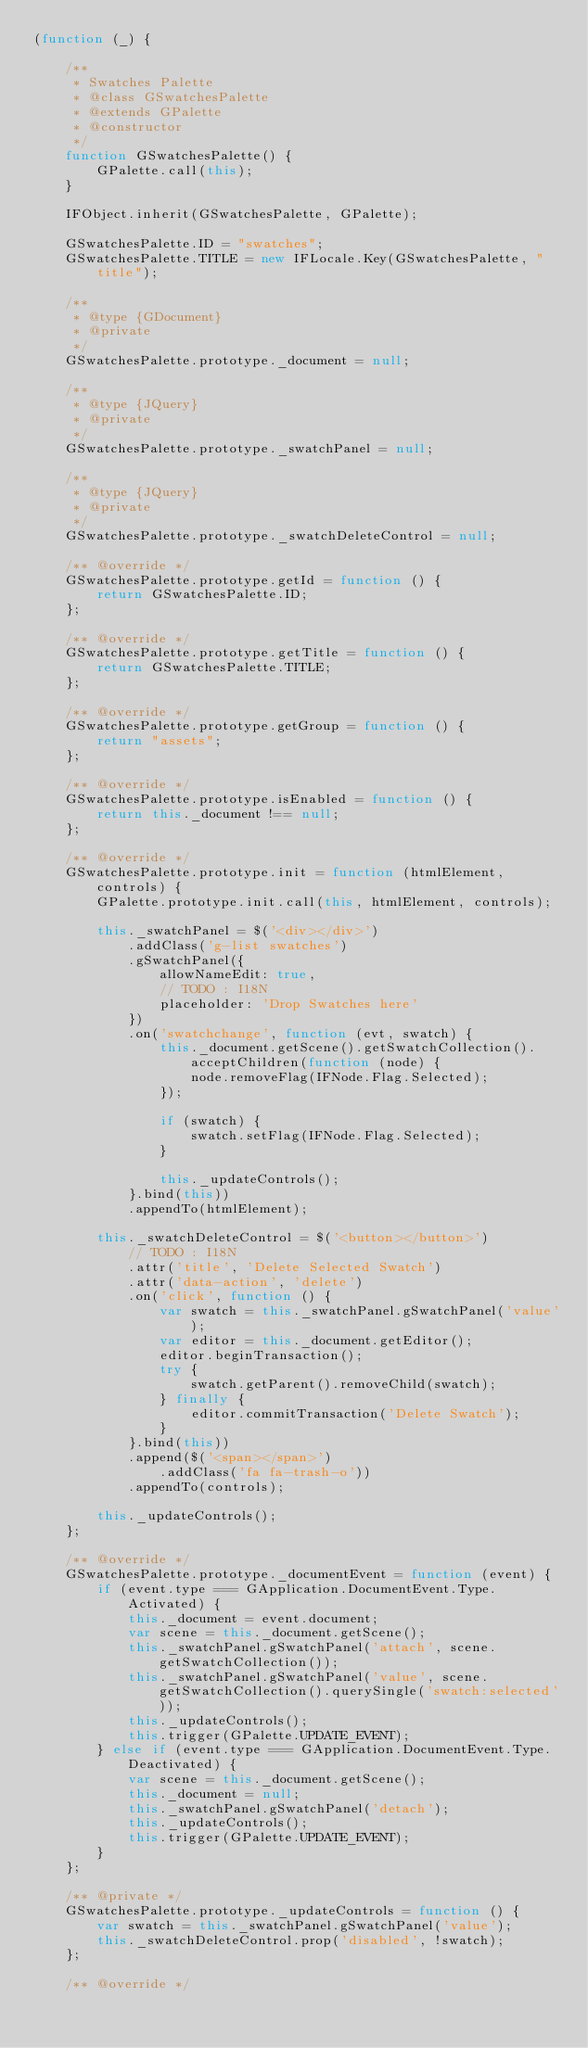<code> <loc_0><loc_0><loc_500><loc_500><_JavaScript_>(function (_) {

    /**
     * Swatches Palette
     * @class GSwatchesPalette
     * @extends GPalette
     * @constructor
     */
    function GSwatchesPalette() {
        GPalette.call(this);
    }

    IFObject.inherit(GSwatchesPalette, GPalette);

    GSwatchesPalette.ID = "swatches";
    GSwatchesPalette.TITLE = new IFLocale.Key(GSwatchesPalette, "title");

    /**
     * @type {GDocument}
     * @private
     */
    GSwatchesPalette.prototype._document = null;

    /**
     * @type {JQuery}
     * @private
     */
    GSwatchesPalette.prototype._swatchPanel = null;

    /**
     * @type {JQuery}
     * @private
     */
    GSwatchesPalette.prototype._swatchDeleteControl = null;

    /** @override */
    GSwatchesPalette.prototype.getId = function () {
        return GSwatchesPalette.ID;
    };

    /** @override */
    GSwatchesPalette.prototype.getTitle = function () {
        return GSwatchesPalette.TITLE;
    };

    /** @override */
    GSwatchesPalette.prototype.getGroup = function () {
        return "assets";
    };

    /** @override */
    GSwatchesPalette.prototype.isEnabled = function () {
        return this._document !== null;
    };

    /** @override */
    GSwatchesPalette.prototype.init = function (htmlElement, controls) {
        GPalette.prototype.init.call(this, htmlElement, controls);

        this._swatchPanel = $('<div></div>')
            .addClass('g-list swatches')
            .gSwatchPanel({
                allowNameEdit: true,
                // TODO : I18N
                placeholder: 'Drop Swatches here'
            })
            .on('swatchchange', function (evt, swatch) {
                this._document.getScene().getSwatchCollection().acceptChildren(function (node) {
                    node.removeFlag(IFNode.Flag.Selected);
                });

                if (swatch) {
                    swatch.setFlag(IFNode.Flag.Selected);
                }

                this._updateControls();
            }.bind(this))
            .appendTo(htmlElement);

        this._swatchDeleteControl = $('<button></button>')
            // TODO : I18N
            .attr('title', 'Delete Selected Swatch')
            .attr('data-action', 'delete')
            .on('click', function () {
                var swatch = this._swatchPanel.gSwatchPanel('value');
                var editor = this._document.getEditor();
                editor.beginTransaction();
                try {
                    swatch.getParent().removeChild(swatch);
                } finally {
                    editor.commitTransaction('Delete Swatch');
                }
            }.bind(this))
            .append($('<span></span>')
                .addClass('fa fa-trash-o'))
            .appendTo(controls);

        this._updateControls();
    };

    /** @override */
    GSwatchesPalette.prototype._documentEvent = function (event) {
        if (event.type === GApplication.DocumentEvent.Type.Activated) {
            this._document = event.document;
            var scene = this._document.getScene();
            this._swatchPanel.gSwatchPanel('attach', scene.getSwatchCollection());
            this._swatchPanel.gSwatchPanel('value', scene.getSwatchCollection().querySingle('swatch:selected'));
            this._updateControls();
            this.trigger(GPalette.UPDATE_EVENT);
        } else if (event.type === GApplication.DocumentEvent.Type.Deactivated) {
            var scene = this._document.getScene();
            this._document = null;
            this._swatchPanel.gSwatchPanel('detach');
            this._updateControls();
            this.trigger(GPalette.UPDATE_EVENT);
        }
    };

    /** @private */
    GSwatchesPalette.prototype._updateControls = function () {
        var swatch = this._swatchPanel.gSwatchPanel('value');
        this._swatchDeleteControl.prop('disabled', !swatch);
    };

    /** @override */</code> 